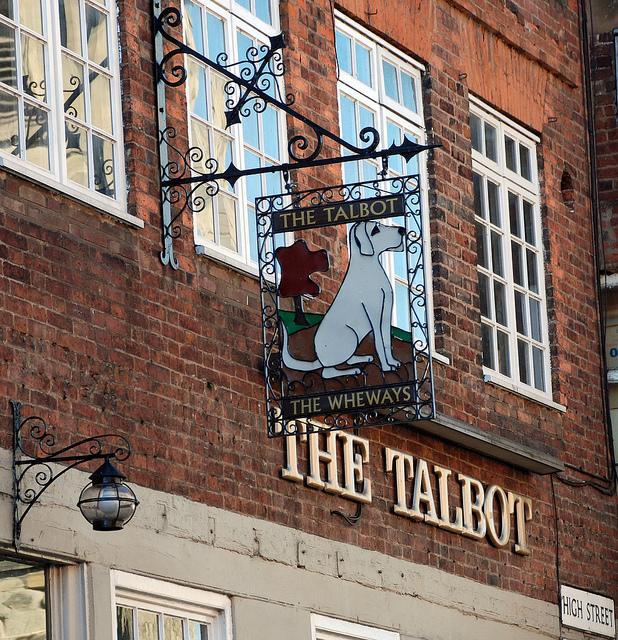How many signs are there?
Keep it brief. 2. What kind of business is The Talbot?
Keep it brief. Bar. How many windows are in the photo?
Concise answer only. 4. What animal does the sign show?
Short answer required. Dog. What does the sign say?
Quick response, please. Talbot. What is the building made of?
Short answer required. Brick. What material is the building made from?
Keep it brief. Brick. 